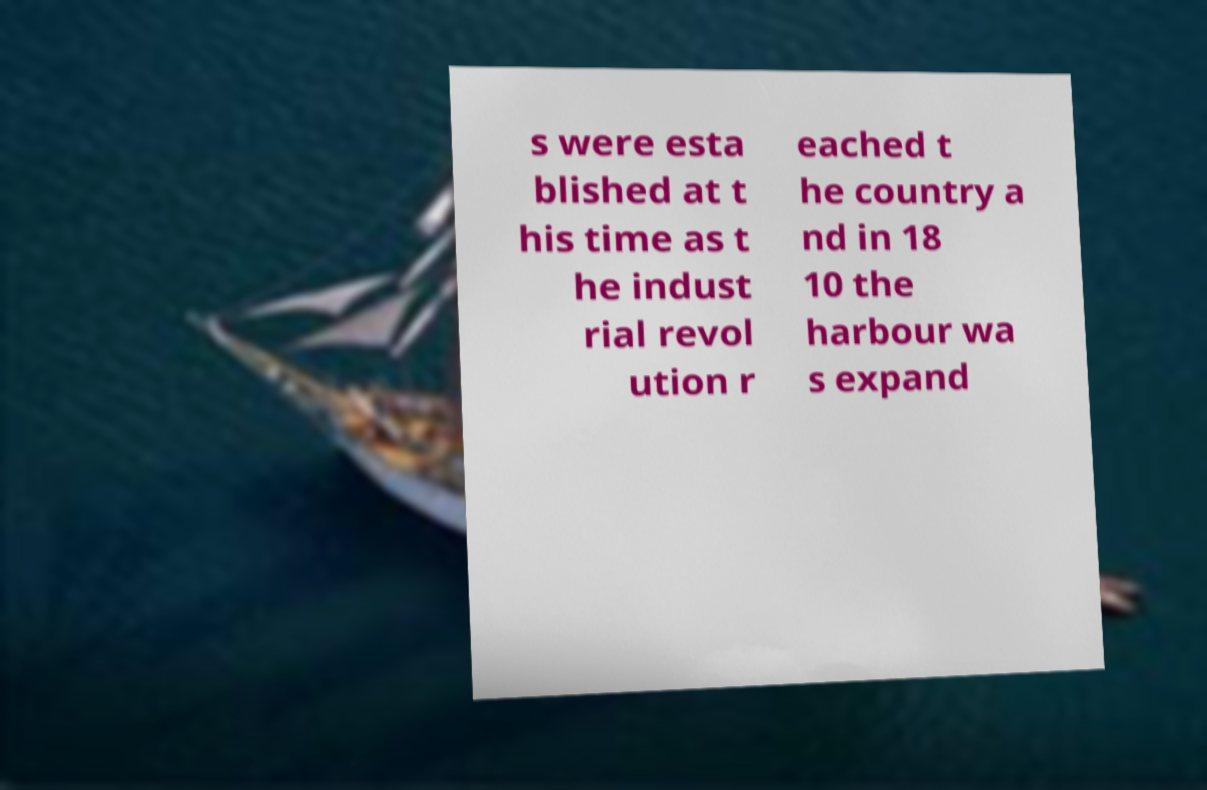There's text embedded in this image that I need extracted. Can you transcribe it verbatim? s were esta blished at t his time as t he indust rial revol ution r eached t he country a nd in 18 10 the harbour wa s expand 